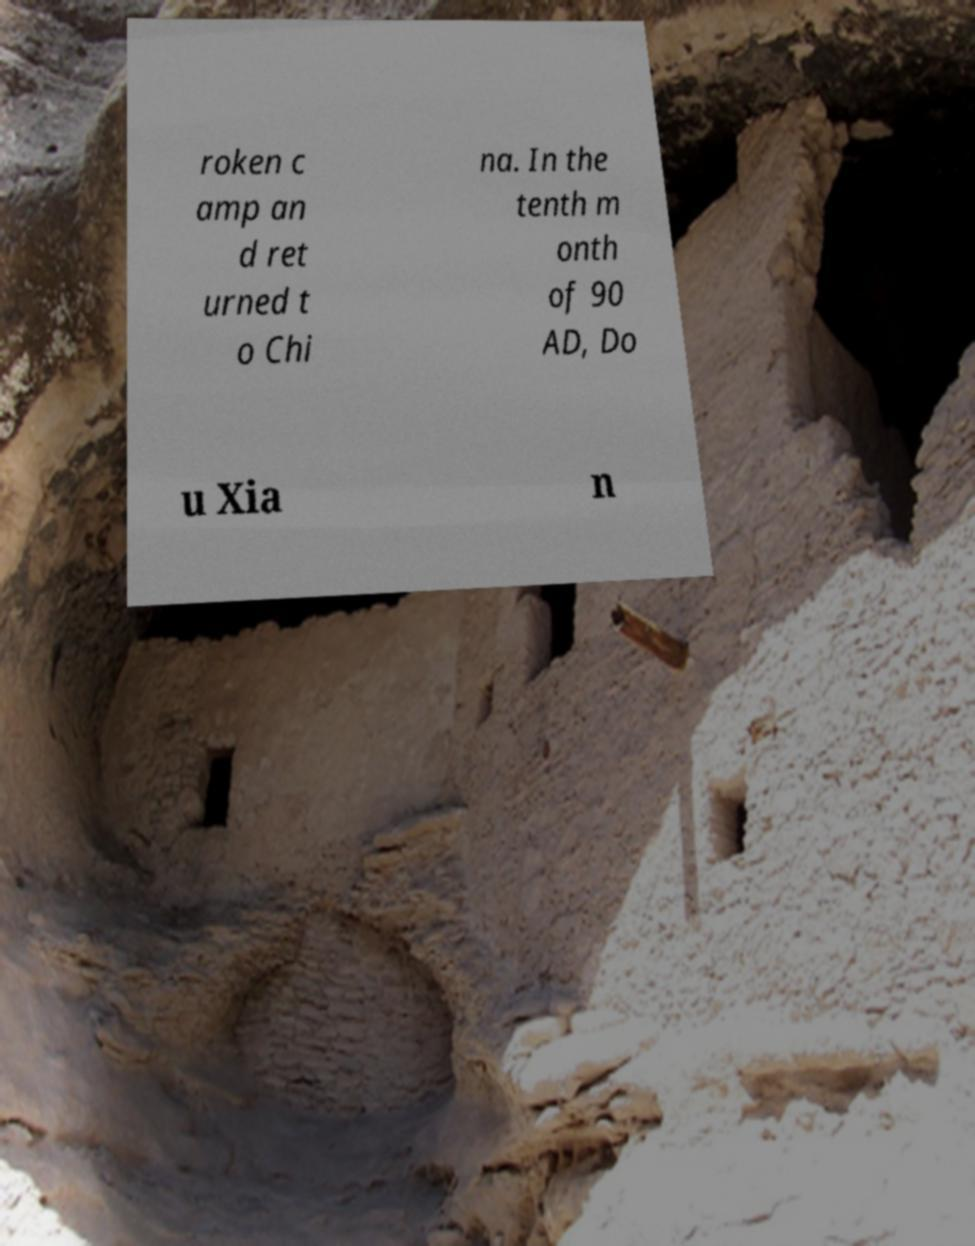What messages or text are displayed in this image? I need them in a readable, typed format. roken c amp an d ret urned t o Chi na. In the tenth m onth of 90 AD, Do u Xia n 